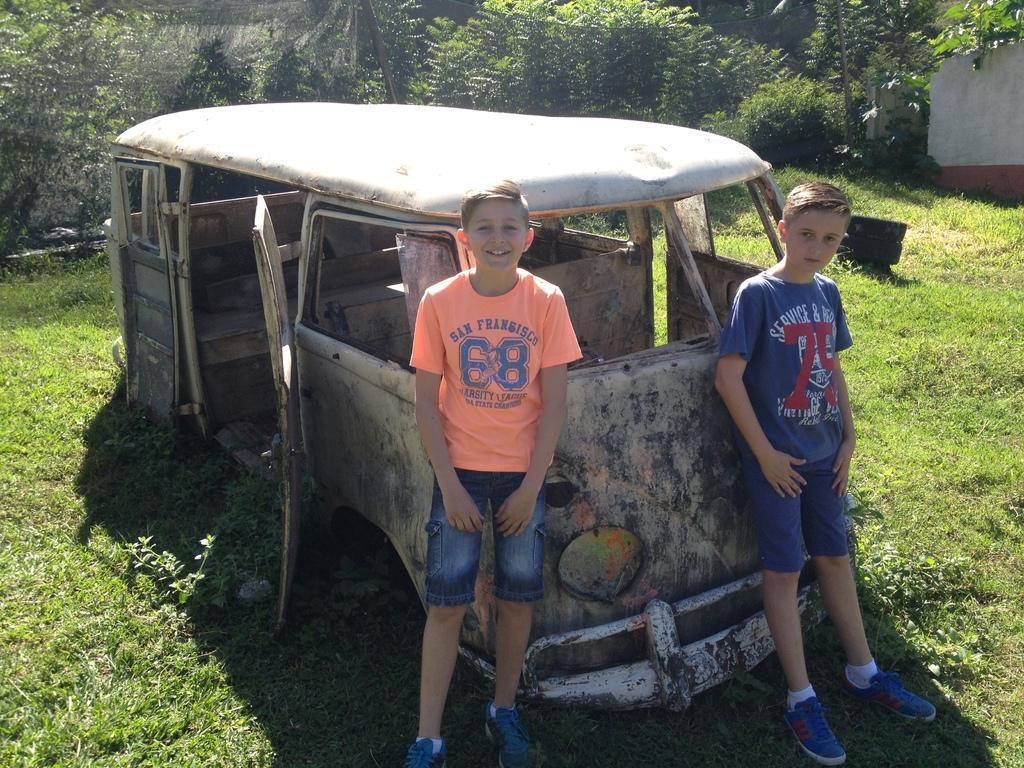Describe this image in one or two sentences. In this picture there are two boys standing. At the back there is a vehicle and there are trees and there is a wall. At the bottom there is grass and there are plants. At the back it looks like a fence. 